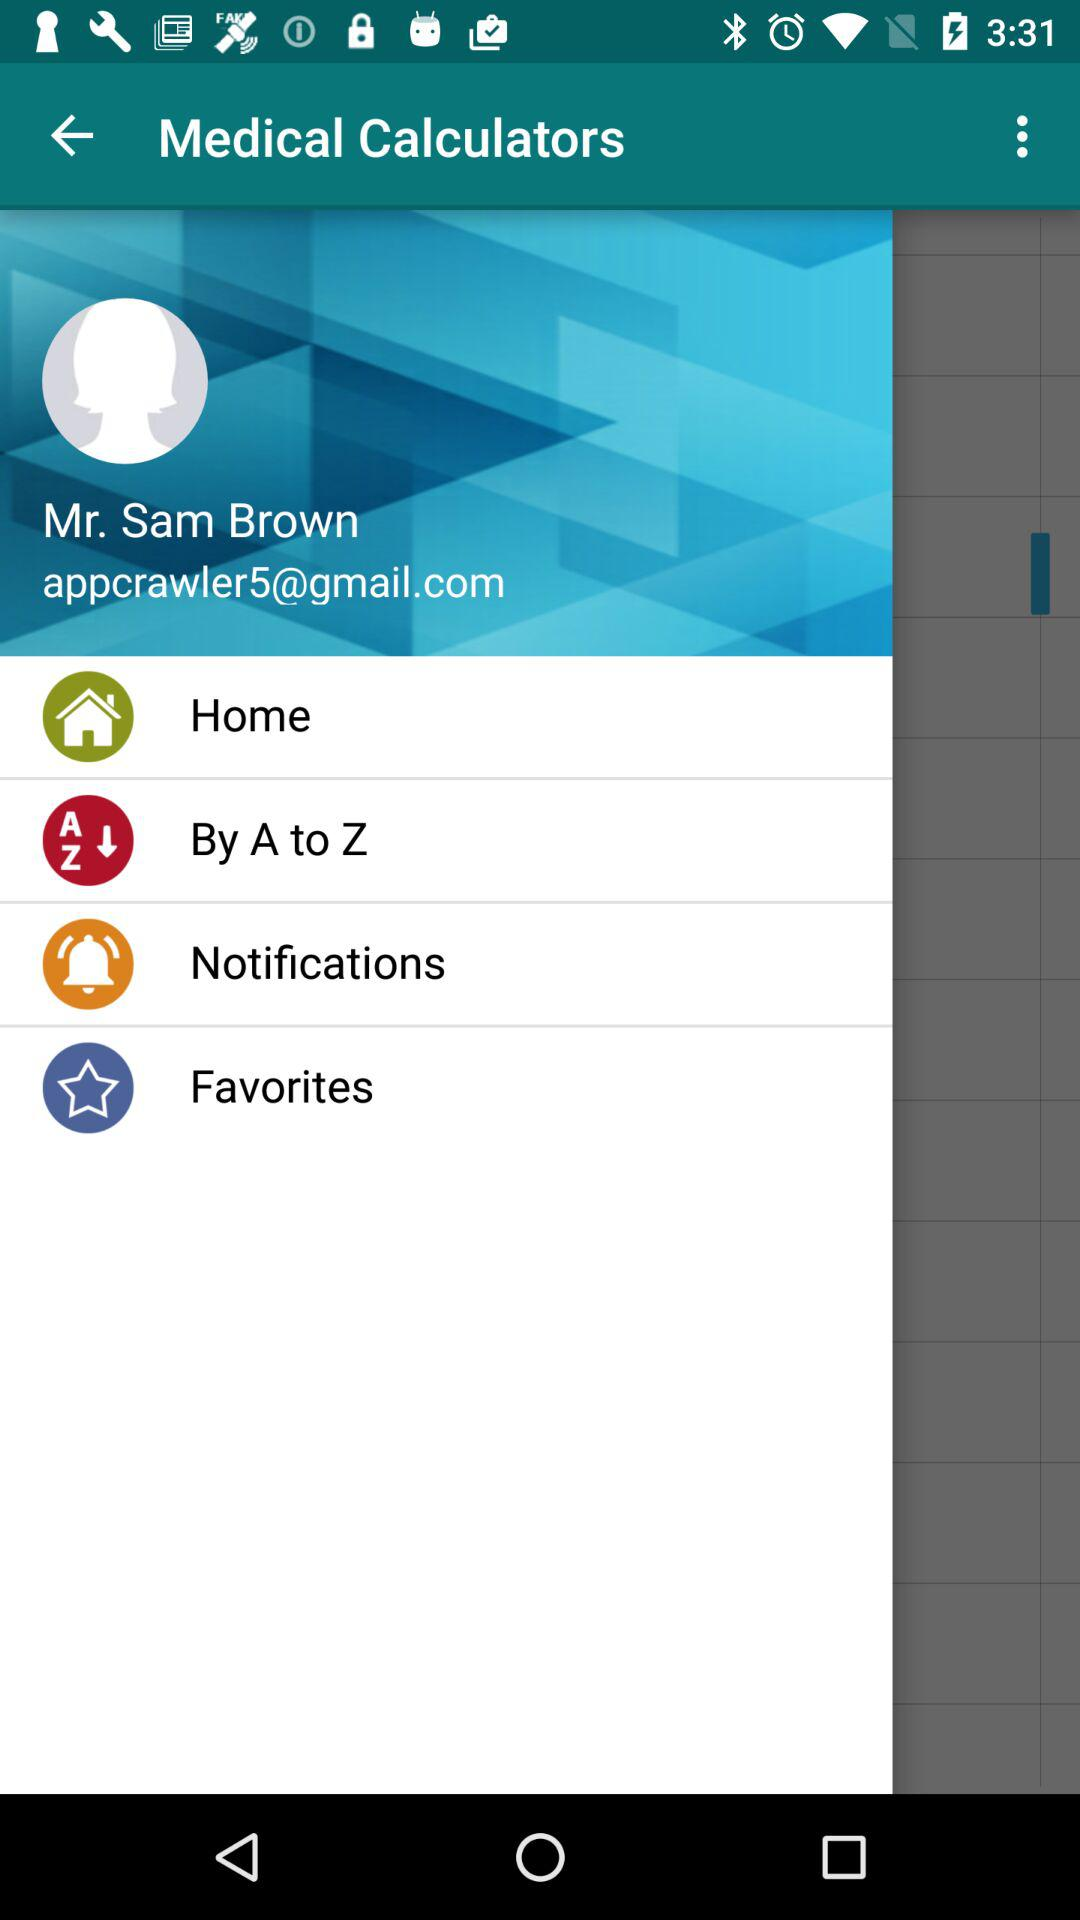What is the email address? The email address is appcrawler5@gmail.com. 